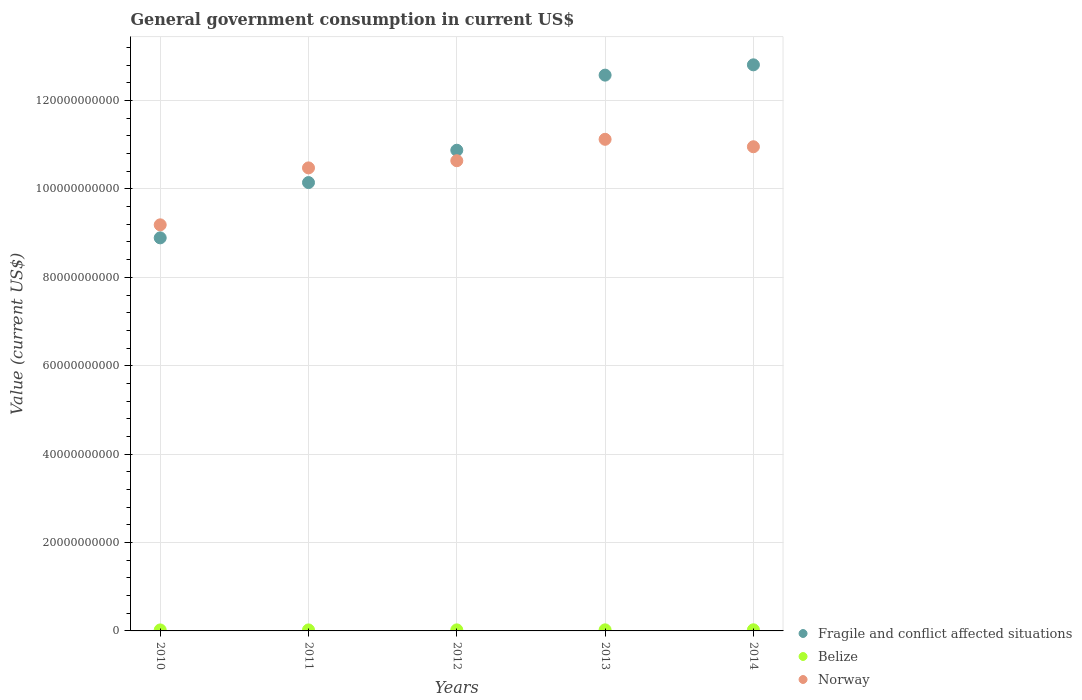How many different coloured dotlines are there?
Offer a very short reply. 3. What is the government conusmption in Fragile and conflict affected situations in 2010?
Provide a short and direct response. 8.89e+1. Across all years, what is the maximum government conusmption in Norway?
Your answer should be very brief. 1.11e+11. Across all years, what is the minimum government conusmption in Norway?
Provide a succinct answer. 9.19e+1. In which year was the government conusmption in Belize maximum?
Keep it short and to the point. 2014. What is the total government conusmption in Norway in the graph?
Keep it short and to the point. 5.24e+11. What is the difference between the government conusmption in Fragile and conflict affected situations in 2011 and that in 2013?
Offer a very short reply. -2.43e+1. What is the difference between the government conusmption in Norway in 2013 and the government conusmption in Fragile and conflict affected situations in 2014?
Keep it short and to the point. -1.69e+1. What is the average government conusmption in Fragile and conflict affected situations per year?
Your answer should be compact. 1.11e+11. In the year 2011, what is the difference between the government conusmption in Norway and government conusmption in Fragile and conflict affected situations?
Provide a short and direct response. 3.32e+09. In how many years, is the government conusmption in Belize greater than 128000000000 US$?
Provide a short and direct response. 0. What is the ratio of the government conusmption in Fragile and conflict affected situations in 2010 to that in 2013?
Make the answer very short. 0.71. Is the government conusmption in Belize in 2013 less than that in 2014?
Your answer should be compact. Yes. What is the difference between the highest and the second highest government conusmption in Fragile and conflict affected situations?
Provide a succinct answer. 2.33e+09. What is the difference between the highest and the lowest government conusmption in Belize?
Your answer should be very brief. 3.18e+07. Does the government conusmption in Norway monotonically increase over the years?
Ensure brevity in your answer.  No. Is the government conusmption in Belize strictly greater than the government conusmption in Fragile and conflict affected situations over the years?
Your response must be concise. No. What is the difference between two consecutive major ticks on the Y-axis?
Ensure brevity in your answer.  2.00e+1. Are the values on the major ticks of Y-axis written in scientific E-notation?
Your response must be concise. No. Does the graph contain grids?
Make the answer very short. Yes. Where does the legend appear in the graph?
Give a very brief answer. Bottom right. How are the legend labels stacked?
Provide a succinct answer. Vertical. What is the title of the graph?
Provide a succinct answer. General government consumption in current US$. Does "Turkey" appear as one of the legend labels in the graph?
Keep it short and to the point. No. What is the label or title of the X-axis?
Offer a very short reply. Years. What is the label or title of the Y-axis?
Provide a succinct answer. Value (current US$). What is the Value (current US$) in Fragile and conflict affected situations in 2010?
Keep it short and to the point. 8.89e+1. What is the Value (current US$) of Belize in 2010?
Provide a succinct answer. 2.23e+08. What is the Value (current US$) of Norway in 2010?
Ensure brevity in your answer.  9.19e+1. What is the Value (current US$) in Fragile and conflict affected situations in 2011?
Offer a terse response. 1.01e+11. What is the Value (current US$) of Belize in 2011?
Keep it short and to the point. 2.29e+08. What is the Value (current US$) in Norway in 2011?
Provide a short and direct response. 1.05e+11. What is the Value (current US$) of Fragile and conflict affected situations in 2012?
Offer a terse response. 1.09e+11. What is the Value (current US$) in Belize in 2012?
Keep it short and to the point. 2.36e+08. What is the Value (current US$) of Norway in 2012?
Ensure brevity in your answer.  1.06e+11. What is the Value (current US$) in Fragile and conflict affected situations in 2013?
Ensure brevity in your answer.  1.26e+11. What is the Value (current US$) in Belize in 2013?
Your answer should be compact. 2.43e+08. What is the Value (current US$) in Norway in 2013?
Make the answer very short. 1.11e+11. What is the Value (current US$) in Fragile and conflict affected situations in 2014?
Give a very brief answer. 1.28e+11. What is the Value (current US$) of Belize in 2014?
Provide a short and direct response. 2.55e+08. What is the Value (current US$) in Norway in 2014?
Provide a succinct answer. 1.10e+11. Across all years, what is the maximum Value (current US$) of Fragile and conflict affected situations?
Your answer should be compact. 1.28e+11. Across all years, what is the maximum Value (current US$) of Belize?
Offer a very short reply. 2.55e+08. Across all years, what is the maximum Value (current US$) in Norway?
Your answer should be very brief. 1.11e+11. Across all years, what is the minimum Value (current US$) of Fragile and conflict affected situations?
Make the answer very short. 8.89e+1. Across all years, what is the minimum Value (current US$) of Belize?
Ensure brevity in your answer.  2.23e+08. Across all years, what is the minimum Value (current US$) in Norway?
Offer a terse response. 9.19e+1. What is the total Value (current US$) of Fragile and conflict affected situations in the graph?
Your response must be concise. 5.53e+11. What is the total Value (current US$) in Belize in the graph?
Your answer should be compact. 1.19e+09. What is the total Value (current US$) of Norway in the graph?
Provide a short and direct response. 5.24e+11. What is the difference between the Value (current US$) in Fragile and conflict affected situations in 2010 and that in 2011?
Give a very brief answer. -1.25e+1. What is the difference between the Value (current US$) of Belize in 2010 and that in 2011?
Keep it short and to the point. -6.58e+06. What is the difference between the Value (current US$) in Norway in 2010 and that in 2011?
Offer a very short reply. -1.29e+1. What is the difference between the Value (current US$) of Fragile and conflict affected situations in 2010 and that in 2012?
Make the answer very short. -1.98e+1. What is the difference between the Value (current US$) in Belize in 2010 and that in 2012?
Keep it short and to the point. -1.30e+07. What is the difference between the Value (current US$) of Norway in 2010 and that in 2012?
Ensure brevity in your answer.  -1.45e+1. What is the difference between the Value (current US$) in Fragile and conflict affected situations in 2010 and that in 2013?
Provide a short and direct response. -3.68e+1. What is the difference between the Value (current US$) of Belize in 2010 and that in 2013?
Keep it short and to the point. -2.05e+07. What is the difference between the Value (current US$) of Norway in 2010 and that in 2013?
Provide a succinct answer. -1.93e+1. What is the difference between the Value (current US$) of Fragile and conflict affected situations in 2010 and that in 2014?
Keep it short and to the point. -3.91e+1. What is the difference between the Value (current US$) of Belize in 2010 and that in 2014?
Your answer should be very brief. -3.18e+07. What is the difference between the Value (current US$) in Norway in 2010 and that in 2014?
Your answer should be very brief. -1.77e+1. What is the difference between the Value (current US$) in Fragile and conflict affected situations in 2011 and that in 2012?
Keep it short and to the point. -7.31e+09. What is the difference between the Value (current US$) of Belize in 2011 and that in 2012?
Make the answer very short. -6.40e+06. What is the difference between the Value (current US$) of Norway in 2011 and that in 2012?
Provide a short and direct response. -1.62e+09. What is the difference between the Value (current US$) in Fragile and conflict affected situations in 2011 and that in 2013?
Your answer should be very brief. -2.43e+1. What is the difference between the Value (current US$) of Belize in 2011 and that in 2013?
Ensure brevity in your answer.  -1.40e+07. What is the difference between the Value (current US$) in Norway in 2011 and that in 2013?
Provide a succinct answer. -6.47e+09. What is the difference between the Value (current US$) in Fragile and conflict affected situations in 2011 and that in 2014?
Provide a succinct answer. -2.66e+1. What is the difference between the Value (current US$) of Belize in 2011 and that in 2014?
Your answer should be compact. -2.52e+07. What is the difference between the Value (current US$) of Norway in 2011 and that in 2014?
Your answer should be very brief. -4.78e+09. What is the difference between the Value (current US$) in Fragile and conflict affected situations in 2012 and that in 2013?
Your answer should be compact. -1.70e+1. What is the difference between the Value (current US$) in Belize in 2012 and that in 2013?
Your response must be concise. -7.55e+06. What is the difference between the Value (current US$) in Norway in 2012 and that in 2013?
Provide a succinct answer. -4.84e+09. What is the difference between the Value (current US$) in Fragile and conflict affected situations in 2012 and that in 2014?
Provide a succinct answer. -1.93e+1. What is the difference between the Value (current US$) of Belize in 2012 and that in 2014?
Your answer should be very brief. -1.88e+07. What is the difference between the Value (current US$) in Norway in 2012 and that in 2014?
Your response must be concise. -3.16e+09. What is the difference between the Value (current US$) in Fragile and conflict affected situations in 2013 and that in 2014?
Provide a short and direct response. -2.33e+09. What is the difference between the Value (current US$) of Belize in 2013 and that in 2014?
Offer a very short reply. -1.12e+07. What is the difference between the Value (current US$) of Norway in 2013 and that in 2014?
Your answer should be compact. 1.68e+09. What is the difference between the Value (current US$) in Fragile and conflict affected situations in 2010 and the Value (current US$) in Belize in 2011?
Your answer should be very brief. 8.87e+1. What is the difference between the Value (current US$) of Fragile and conflict affected situations in 2010 and the Value (current US$) of Norway in 2011?
Give a very brief answer. -1.58e+1. What is the difference between the Value (current US$) in Belize in 2010 and the Value (current US$) in Norway in 2011?
Provide a succinct answer. -1.05e+11. What is the difference between the Value (current US$) in Fragile and conflict affected situations in 2010 and the Value (current US$) in Belize in 2012?
Make the answer very short. 8.87e+1. What is the difference between the Value (current US$) in Fragile and conflict affected situations in 2010 and the Value (current US$) in Norway in 2012?
Your answer should be compact. -1.75e+1. What is the difference between the Value (current US$) of Belize in 2010 and the Value (current US$) of Norway in 2012?
Make the answer very short. -1.06e+11. What is the difference between the Value (current US$) of Fragile and conflict affected situations in 2010 and the Value (current US$) of Belize in 2013?
Your answer should be compact. 8.87e+1. What is the difference between the Value (current US$) in Fragile and conflict affected situations in 2010 and the Value (current US$) in Norway in 2013?
Give a very brief answer. -2.23e+1. What is the difference between the Value (current US$) in Belize in 2010 and the Value (current US$) in Norway in 2013?
Give a very brief answer. -1.11e+11. What is the difference between the Value (current US$) of Fragile and conflict affected situations in 2010 and the Value (current US$) of Belize in 2014?
Offer a very short reply. 8.87e+1. What is the difference between the Value (current US$) in Fragile and conflict affected situations in 2010 and the Value (current US$) in Norway in 2014?
Provide a short and direct response. -2.06e+1. What is the difference between the Value (current US$) in Belize in 2010 and the Value (current US$) in Norway in 2014?
Keep it short and to the point. -1.09e+11. What is the difference between the Value (current US$) of Fragile and conflict affected situations in 2011 and the Value (current US$) of Belize in 2012?
Provide a succinct answer. 1.01e+11. What is the difference between the Value (current US$) of Fragile and conflict affected situations in 2011 and the Value (current US$) of Norway in 2012?
Your answer should be very brief. -4.94e+09. What is the difference between the Value (current US$) of Belize in 2011 and the Value (current US$) of Norway in 2012?
Give a very brief answer. -1.06e+11. What is the difference between the Value (current US$) in Fragile and conflict affected situations in 2011 and the Value (current US$) in Belize in 2013?
Provide a short and direct response. 1.01e+11. What is the difference between the Value (current US$) in Fragile and conflict affected situations in 2011 and the Value (current US$) in Norway in 2013?
Give a very brief answer. -9.79e+09. What is the difference between the Value (current US$) of Belize in 2011 and the Value (current US$) of Norway in 2013?
Your answer should be compact. -1.11e+11. What is the difference between the Value (current US$) of Fragile and conflict affected situations in 2011 and the Value (current US$) of Belize in 2014?
Provide a short and direct response. 1.01e+11. What is the difference between the Value (current US$) of Fragile and conflict affected situations in 2011 and the Value (current US$) of Norway in 2014?
Your answer should be very brief. -8.10e+09. What is the difference between the Value (current US$) in Belize in 2011 and the Value (current US$) in Norway in 2014?
Make the answer very short. -1.09e+11. What is the difference between the Value (current US$) in Fragile and conflict affected situations in 2012 and the Value (current US$) in Belize in 2013?
Your answer should be very brief. 1.09e+11. What is the difference between the Value (current US$) in Fragile and conflict affected situations in 2012 and the Value (current US$) in Norway in 2013?
Your response must be concise. -2.47e+09. What is the difference between the Value (current US$) of Belize in 2012 and the Value (current US$) of Norway in 2013?
Your answer should be compact. -1.11e+11. What is the difference between the Value (current US$) of Fragile and conflict affected situations in 2012 and the Value (current US$) of Belize in 2014?
Provide a succinct answer. 1.09e+11. What is the difference between the Value (current US$) of Fragile and conflict affected situations in 2012 and the Value (current US$) of Norway in 2014?
Your response must be concise. -7.91e+08. What is the difference between the Value (current US$) of Belize in 2012 and the Value (current US$) of Norway in 2014?
Keep it short and to the point. -1.09e+11. What is the difference between the Value (current US$) in Fragile and conflict affected situations in 2013 and the Value (current US$) in Belize in 2014?
Your response must be concise. 1.25e+11. What is the difference between the Value (current US$) of Fragile and conflict affected situations in 2013 and the Value (current US$) of Norway in 2014?
Give a very brief answer. 1.62e+1. What is the difference between the Value (current US$) of Belize in 2013 and the Value (current US$) of Norway in 2014?
Make the answer very short. -1.09e+11. What is the average Value (current US$) in Fragile and conflict affected situations per year?
Offer a terse response. 1.11e+11. What is the average Value (current US$) in Belize per year?
Your response must be concise. 2.37e+08. What is the average Value (current US$) in Norway per year?
Ensure brevity in your answer.  1.05e+11. In the year 2010, what is the difference between the Value (current US$) of Fragile and conflict affected situations and Value (current US$) of Belize?
Give a very brief answer. 8.87e+1. In the year 2010, what is the difference between the Value (current US$) in Fragile and conflict affected situations and Value (current US$) in Norway?
Provide a short and direct response. -2.95e+09. In the year 2010, what is the difference between the Value (current US$) in Belize and Value (current US$) in Norway?
Ensure brevity in your answer.  -9.17e+1. In the year 2011, what is the difference between the Value (current US$) of Fragile and conflict affected situations and Value (current US$) of Belize?
Give a very brief answer. 1.01e+11. In the year 2011, what is the difference between the Value (current US$) of Fragile and conflict affected situations and Value (current US$) of Norway?
Your response must be concise. -3.32e+09. In the year 2011, what is the difference between the Value (current US$) of Belize and Value (current US$) of Norway?
Offer a terse response. -1.05e+11. In the year 2012, what is the difference between the Value (current US$) in Fragile and conflict affected situations and Value (current US$) in Belize?
Keep it short and to the point. 1.09e+11. In the year 2012, what is the difference between the Value (current US$) of Fragile and conflict affected situations and Value (current US$) of Norway?
Make the answer very short. 2.37e+09. In the year 2012, what is the difference between the Value (current US$) of Belize and Value (current US$) of Norway?
Ensure brevity in your answer.  -1.06e+11. In the year 2013, what is the difference between the Value (current US$) of Fragile and conflict affected situations and Value (current US$) of Belize?
Make the answer very short. 1.26e+11. In the year 2013, what is the difference between the Value (current US$) in Fragile and conflict affected situations and Value (current US$) in Norway?
Offer a very short reply. 1.45e+1. In the year 2013, what is the difference between the Value (current US$) in Belize and Value (current US$) in Norway?
Ensure brevity in your answer.  -1.11e+11. In the year 2014, what is the difference between the Value (current US$) in Fragile and conflict affected situations and Value (current US$) in Belize?
Give a very brief answer. 1.28e+11. In the year 2014, what is the difference between the Value (current US$) in Fragile and conflict affected situations and Value (current US$) in Norway?
Offer a terse response. 1.85e+1. In the year 2014, what is the difference between the Value (current US$) of Belize and Value (current US$) of Norway?
Make the answer very short. -1.09e+11. What is the ratio of the Value (current US$) of Fragile and conflict affected situations in 2010 to that in 2011?
Offer a very short reply. 0.88. What is the ratio of the Value (current US$) in Belize in 2010 to that in 2011?
Offer a very short reply. 0.97. What is the ratio of the Value (current US$) in Norway in 2010 to that in 2011?
Your answer should be very brief. 0.88. What is the ratio of the Value (current US$) of Fragile and conflict affected situations in 2010 to that in 2012?
Provide a short and direct response. 0.82. What is the ratio of the Value (current US$) in Belize in 2010 to that in 2012?
Your answer should be very brief. 0.94. What is the ratio of the Value (current US$) in Norway in 2010 to that in 2012?
Keep it short and to the point. 0.86. What is the ratio of the Value (current US$) of Fragile and conflict affected situations in 2010 to that in 2013?
Your response must be concise. 0.71. What is the ratio of the Value (current US$) in Belize in 2010 to that in 2013?
Your answer should be compact. 0.92. What is the ratio of the Value (current US$) in Norway in 2010 to that in 2013?
Give a very brief answer. 0.83. What is the ratio of the Value (current US$) of Fragile and conflict affected situations in 2010 to that in 2014?
Provide a succinct answer. 0.69. What is the ratio of the Value (current US$) of Belize in 2010 to that in 2014?
Provide a short and direct response. 0.88. What is the ratio of the Value (current US$) in Norway in 2010 to that in 2014?
Ensure brevity in your answer.  0.84. What is the ratio of the Value (current US$) of Fragile and conflict affected situations in 2011 to that in 2012?
Make the answer very short. 0.93. What is the ratio of the Value (current US$) in Belize in 2011 to that in 2012?
Your answer should be compact. 0.97. What is the ratio of the Value (current US$) in Norway in 2011 to that in 2012?
Offer a very short reply. 0.98. What is the ratio of the Value (current US$) in Fragile and conflict affected situations in 2011 to that in 2013?
Keep it short and to the point. 0.81. What is the ratio of the Value (current US$) in Belize in 2011 to that in 2013?
Your answer should be very brief. 0.94. What is the ratio of the Value (current US$) of Norway in 2011 to that in 2013?
Provide a short and direct response. 0.94. What is the ratio of the Value (current US$) in Fragile and conflict affected situations in 2011 to that in 2014?
Make the answer very short. 0.79. What is the ratio of the Value (current US$) in Belize in 2011 to that in 2014?
Your answer should be very brief. 0.9. What is the ratio of the Value (current US$) in Norway in 2011 to that in 2014?
Your answer should be compact. 0.96. What is the ratio of the Value (current US$) in Fragile and conflict affected situations in 2012 to that in 2013?
Offer a very short reply. 0.86. What is the ratio of the Value (current US$) of Belize in 2012 to that in 2013?
Offer a terse response. 0.97. What is the ratio of the Value (current US$) in Norway in 2012 to that in 2013?
Your answer should be compact. 0.96. What is the ratio of the Value (current US$) in Fragile and conflict affected situations in 2012 to that in 2014?
Ensure brevity in your answer.  0.85. What is the ratio of the Value (current US$) in Belize in 2012 to that in 2014?
Your answer should be compact. 0.93. What is the ratio of the Value (current US$) of Norway in 2012 to that in 2014?
Keep it short and to the point. 0.97. What is the ratio of the Value (current US$) of Fragile and conflict affected situations in 2013 to that in 2014?
Your answer should be very brief. 0.98. What is the ratio of the Value (current US$) of Belize in 2013 to that in 2014?
Your answer should be compact. 0.96. What is the ratio of the Value (current US$) of Norway in 2013 to that in 2014?
Ensure brevity in your answer.  1.02. What is the difference between the highest and the second highest Value (current US$) of Fragile and conflict affected situations?
Provide a short and direct response. 2.33e+09. What is the difference between the highest and the second highest Value (current US$) of Belize?
Your answer should be compact. 1.12e+07. What is the difference between the highest and the second highest Value (current US$) of Norway?
Your response must be concise. 1.68e+09. What is the difference between the highest and the lowest Value (current US$) in Fragile and conflict affected situations?
Provide a short and direct response. 3.91e+1. What is the difference between the highest and the lowest Value (current US$) in Belize?
Make the answer very short. 3.18e+07. What is the difference between the highest and the lowest Value (current US$) of Norway?
Offer a very short reply. 1.93e+1. 